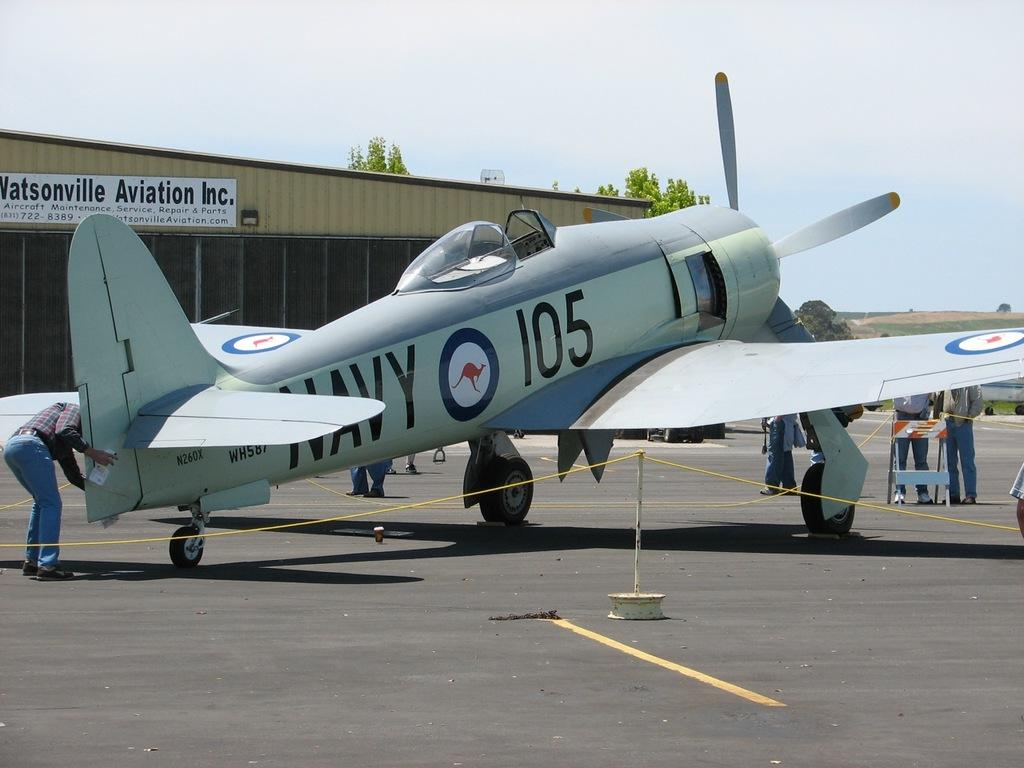<image>
Offer a succinct explanation of the picture presented. At Watsonville Aviation Inc. a man adjusts an old fashioned propeller plane with "Navy 105" painted on the side. 